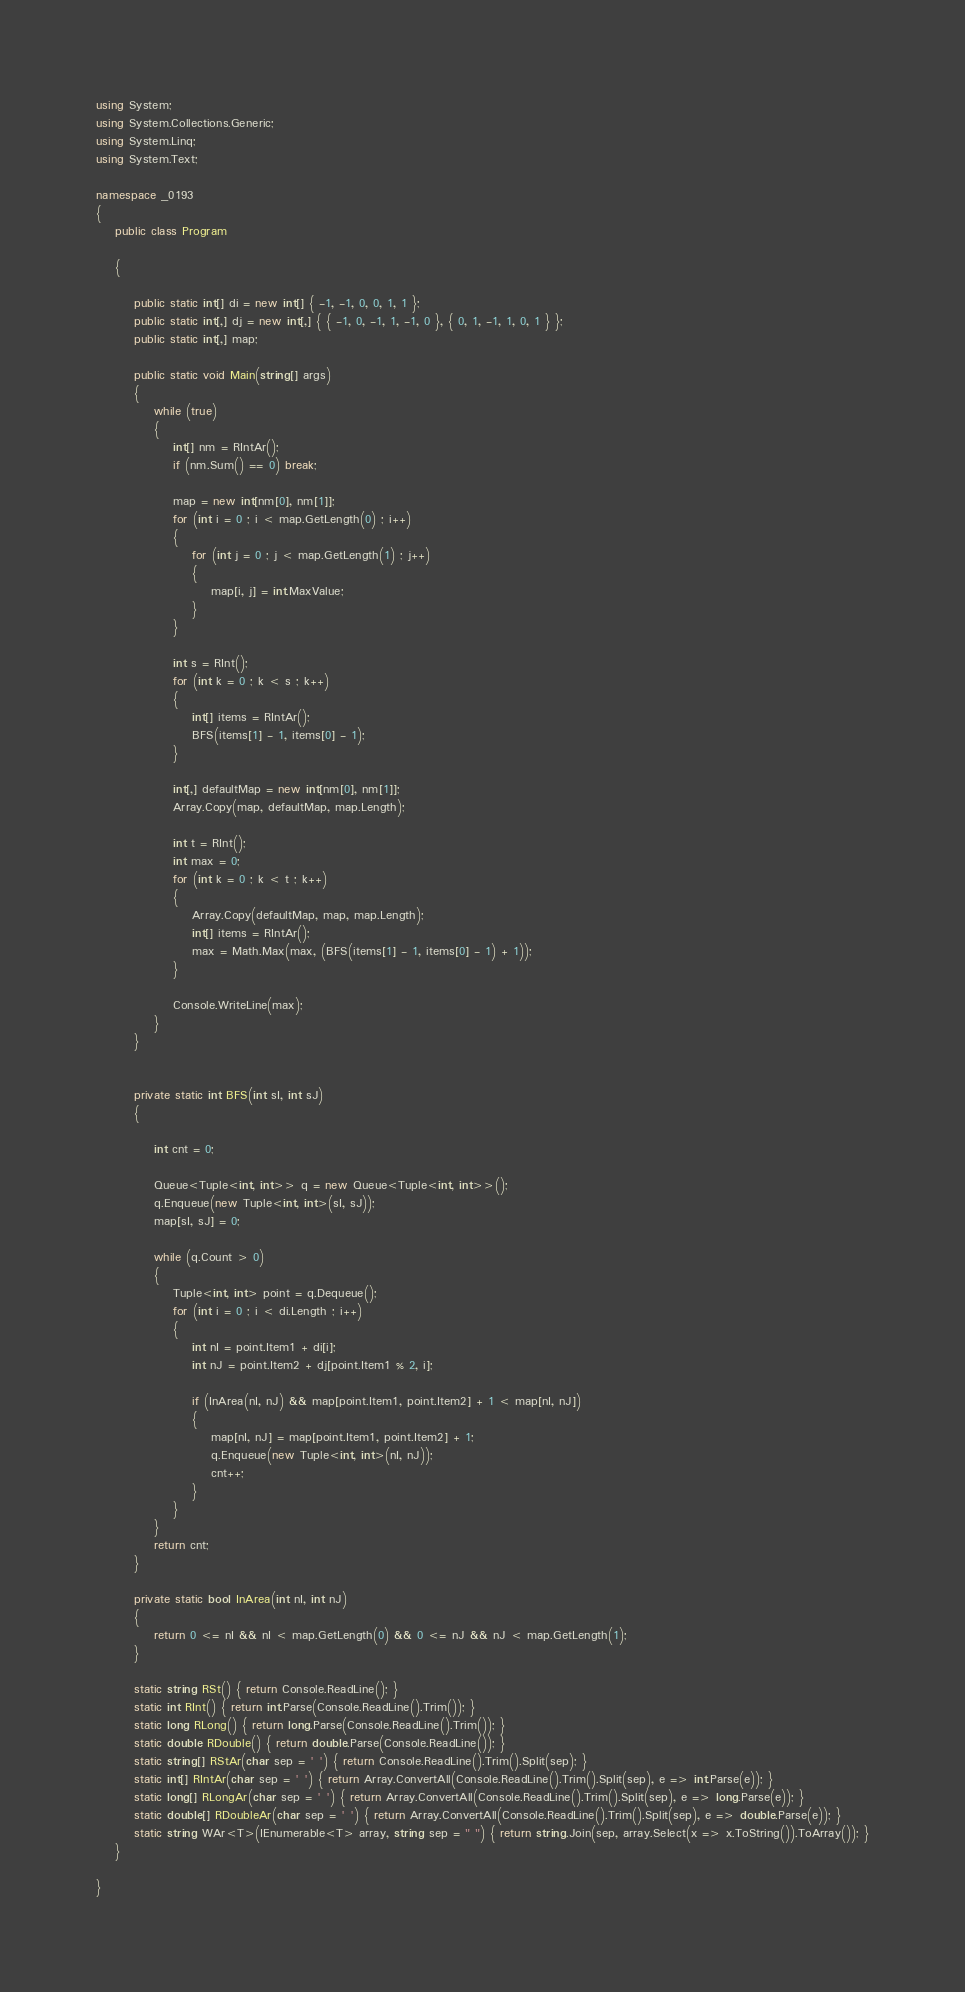<code> <loc_0><loc_0><loc_500><loc_500><_C#_>using System;
using System.Collections.Generic;
using System.Linq;
using System.Text;

namespace _0193
{
    public class Program

    {

        public static int[] di = new int[] { -1, -1, 0, 0, 1, 1 };
        public static int[,] dj = new int[,] { { -1, 0, -1, 1, -1, 0 }, { 0, 1, -1, 1, 0, 1 } };
        public static int[,] map;

        public static void Main(string[] args)
        {
            while (true)
            {
                int[] nm = RIntAr();
                if (nm.Sum() == 0) break;

                map = new int[nm[0], nm[1]];
                for (int i = 0 ; i < map.GetLength(0) ; i++)
                {
                    for (int j = 0 ; j < map.GetLength(1) ; j++)
                    {
                        map[i, j] = int.MaxValue;
                    }
                }

                int s = RInt();
                for (int k = 0 ; k < s ; k++)
                {
                    int[] items = RIntAr();
                    BFS(items[1] - 1, items[0] - 1);
                }

                int[,] defaultMap = new int[nm[0], nm[1]];
                Array.Copy(map, defaultMap, map.Length);

                int t = RInt();
                int max = 0;
                for (int k = 0 ; k < t ; k++)
                {
                    Array.Copy(defaultMap, map, map.Length);
                    int[] items = RIntAr();
                    max = Math.Max(max, (BFS(items[1] - 1, items[0] - 1) + 1));          
                }

                Console.WriteLine(max);
            }
        }


        private static int BFS(int sI, int sJ)
        {

            int cnt = 0;

            Queue<Tuple<int, int>> q = new Queue<Tuple<int, int>>();
            q.Enqueue(new Tuple<int, int>(sI, sJ));
            map[sI, sJ] = 0;

            while (q.Count > 0)
            {
                Tuple<int, int> point = q.Dequeue();
                for (int i = 0 ; i < di.Length ; i++)
                {
                    int nI = point.Item1 + di[i];
                    int nJ = point.Item2 + dj[point.Item1 % 2, i];

                    if (InArea(nI, nJ) && map[point.Item1, point.Item2] + 1 < map[nI, nJ])
                    {
                        map[nI, nJ] = map[point.Item1, point.Item2] + 1;
                        q.Enqueue(new Tuple<int, int>(nI, nJ));
                        cnt++;
                    }
                }
            }
            return cnt;
        }

        private static bool InArea(int nI, int nJ)
        {
            return 0 <= nI && nI < map.GetLength(0) && 0 <= nJ && nJ < map.GetLength(1);
        }

        static string RSt() { return Console.ReadLine(); }
        static int RInt() { return int.Parse(Console.ReadLine().Trim()); }
        static long RLong() { return long.Parse(Console.ReadLine().Trim()); }
        static double RDouble() { return double.Parse(Console.ReadLine()); }
        static string[] RStAr(char sep = ' ') { return Console.ReadLine().Trim().Split(sep); }
        static int[] RIntAr(char sep = ' ') { return Array.ConvertAll(Console.ReadLine().Trim().Split(sep), e => int.Parse(e)); }
        static long[] RLongAr(char sep = ' ') { return Array.ConvertAll(Console.ReadLine().Trim().Split(sep), e => long.Parse(e)); }
        static double[] RDoubleAr(char sep = ' ') { return Array.ConvertAll(Console.ReadLine().Trim().Split(sep), e => double.Parse(e)); }
        static string WAr<T>(IEnumerable<T> array, string sep = " ") { return string.Join(sep, array.Select(x => x.ToString()).ToArray()); }
    }

}

</code> 